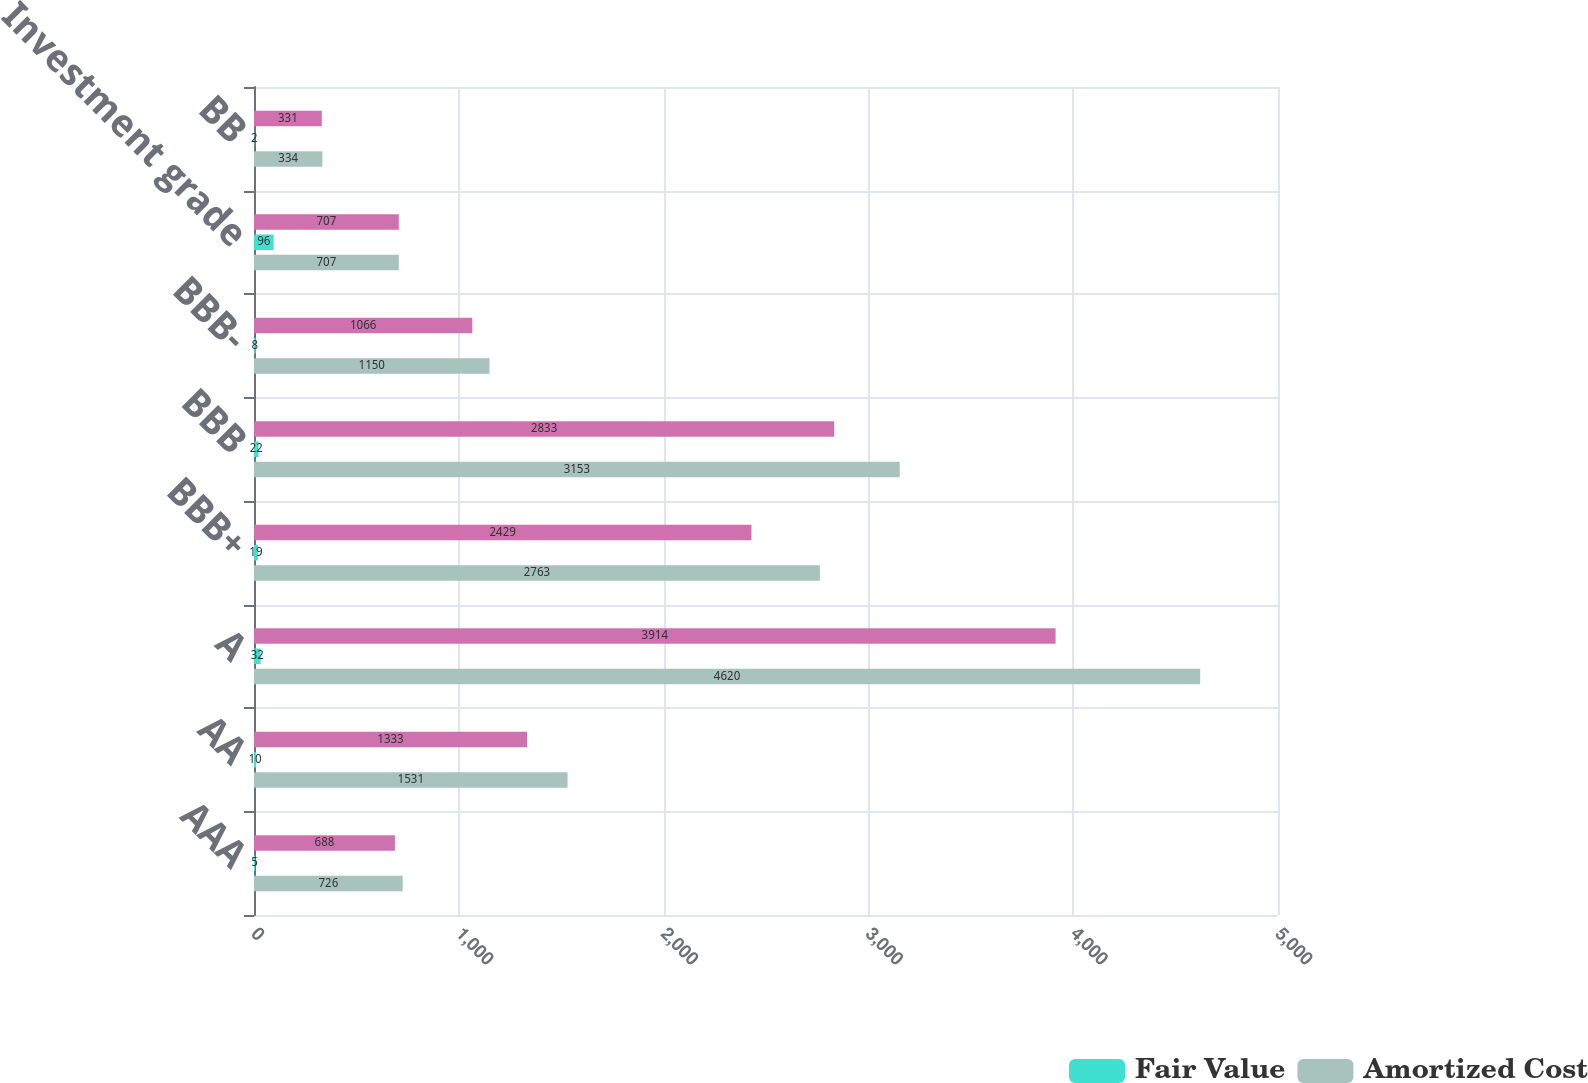<chart> <loc_0><loc_0><loc_500><loc_500><stacked_bar_chart><ecel><fcel>AAA<fcel>AA<fcel>A<fcel>BBB+<fcel>BBB<fcel>BBB-<fcel>Investment grade<fcel>BB<nl><fcel>nan<fcel>688<fcel>1333<fcel>3914<fcel>2429<fcel>2833<fcel>1066<fcel>707<fcel>331<nl><fcel>Fair Value<fcel>5<fcel>10<fcel>32<fcel>19<fcel>22<fcel>8<fcel>96<fcel>2<nl><fcel>Amortized Cost<fcel>726<fcel>1531<fcel>4620<fcel>2763<fcel>3153<fcel>1150<fcel>707<fcel>334<nl></chart> 